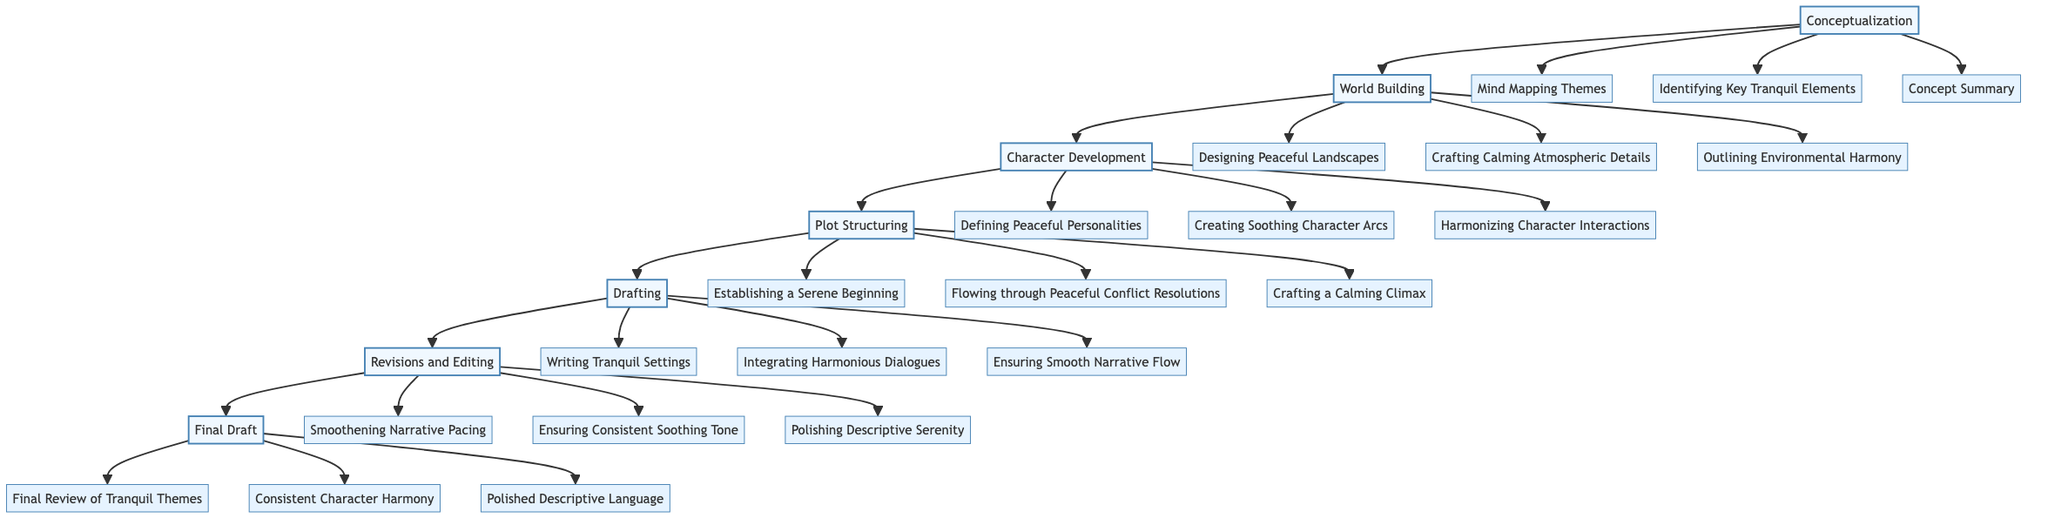What is the first stage in the plot development process? The first stage listed in the flowchart is "Conceptualization," as it precedes all other stages in the diagram.
Answer: Conceptualization How many key milestones are associated with "Character Development"? In the diagram, "Character Development" has three associated milestones: "Defining Peaceful Personalities," "Creating Soothing Character Arcs," and "Harmonizing Character Interactions."
Answer: 3 What is the last stage before the final draft? The penultimate stage in the flowchart is "Revisions and Editing," which proceeds right before the "Final Draft" node.
Answer: Revisions and Editing Which stage involves writing tranquil settings? "Drafting" is the stage that includes the milestone of "Writing Tranquil Settings," focusing on creating a serene narrative atmosphere.
Answer: Drafting Which two stages are directly connected to "Plot Structuring"? The diagram shows "Character Development" leading directly into "Plot Structuring," and after "Plot Structuring," it connects to "Drafting," establishing a clear flow through these stages.
Answer: Character Development and Drafting What is the primary focus during the "Revisions and Editing" stage? The core focus during "Revisions and Editing" is enhancing the tranquility of the narrative, specifically through milestones like "Smoothening Narrative Pacing," "Ensuring Consistent Soothing Tone," and "Polishing Descriptive Serenity."
Answer: Enhancing tranquility How many stages are outlined in the plot development process? The flowchart lists a total of seven distinct stages that encompass the complete plot development process from conceptualization to the final draft.
Answer: 7 What milestone is associated with ensuring smooth narrative flow? The milestone "Ensuring Smooth Narrative Flow" is part of the "Drafting" stage, indicating it is crucial in composing the narrative.
Answer: Ensuring Smooth Narrative Flow Which stage precedes "World Building"? "Conceptualization" is the stage that occurs before "World Building" in the flowchart, indicating the initial brainstorming process.
Answer: Conceptualization 